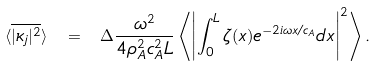<formula> <loc_0><loc_0><loc_500><loc_500>\langle \overline { | \kappa _ { j } | ^ { 2 } } \rangle \ = \ \Delta \frac { \omega ^ { 2 } } { 4 \rho _ { A } ^ { 2 } c _ { A } ^ { 2 } L } \left \langle \left | \int _ { 0 } ^ { L } \zeta ( x ) e ^ { - 2 i \omega x / c _ { A } } d x \right | ^ { 2 } \right \rangle .</formula> 